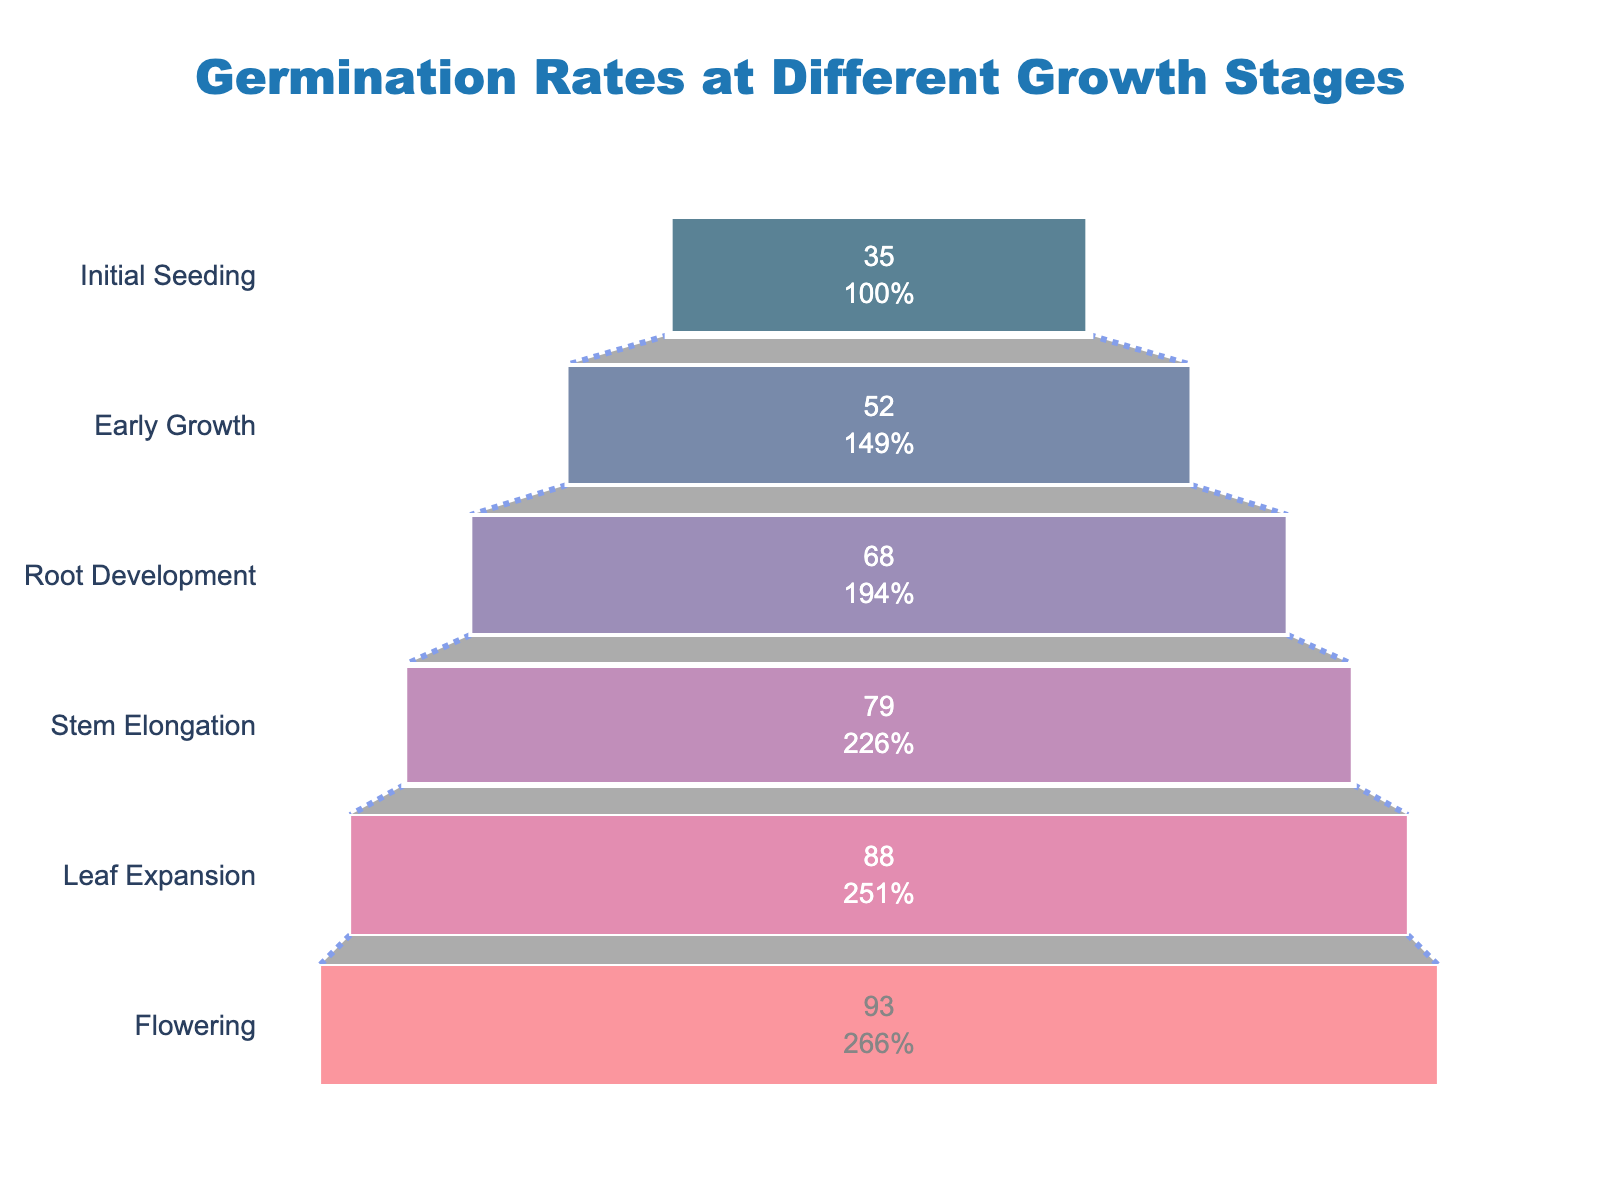What's the title of the figure? The title of the figure is usually found at the top. It reads "Germination Rates at Different Growth Stages."
Answer: Germination Rates at Different Growth Stages How many growth stages are shown in the chart? By counting the labels on the y-axis, we can see there are six stages listed: "Initial Seeding", "Early Growth", "Root Development", "Stem Elongation", "Leaf Expansion", "Flowering".
Answer: Six stages What is the germination rate at the "Stem Elongation" stage? Locate "Stem Elongation" on the y-axis and trace it horizontally to see the germination rate percentage. It is marked at 79%.
Answer: 79% By how much does the germination rate change from "Initial Seeding" to "Root Development"? Subtract the germination rate at "Initial Seeding" (35%) from the rate at "Root Development" (68%). The calculation is 68% - 35%. Therefore, the change is 33%.
Answer: 33% Which stage has the highest germination rate, and what is it? Scan horizontally along the top of the funnel chart and identify the highest germination rate, which is at the "Flowering" stage. The rate is 93%.
Answer: Flowering stage, 93% What is the average germination rate across all stages? Add all germination rates: 35% + 52% + 68% + 79% + 88% + 93% = 415%. Then, divide by the number of stages (6). The average is 415% / 6 ≈ 69.2%.
Answer: 69.2% Which stage has the lowest soil moisture level, and what is it? Locate the soil moisture levels on the stages listed from "Initial Seeding" to "Flowering". The "Initial Seeding" stage has the lowest soil moisture level of 10%.
Answer: Initial Seeding stage, 10% How does the germination rate change as soil moisture levels increase from 10% to 30%? Track the progression of germination rates as soil moisture increases from 10% to 30%. The rates move from 35% to 88%. Thus, the increase is 88% - 35% = 53%.
Answer: 53% Compare the increase in germination rate from "Early Growth" to "Leaf Expansion" with the increase from "Initial Seeding" to "Early Growth." The increase from "Early Growth" (52%) to "Leaf Expansion" (88%) is 88% - 52% = 36%. The increase from "Initial Seeding" (35%) to "Early Growth" (52%) is 52% - 35% = 17%.
Answer: 36% and 17% What is the average soil moisture level at the last three growth stages? Add the soil moisture levels at the last three stages: 30% ("Leaf Expansion") + 35% ("Flowering") + 25% ("Stem Elongation") = 90%. Then, divide by the number of stages (3). The average is 90% / 3 = 30%.
Answer: 30% 